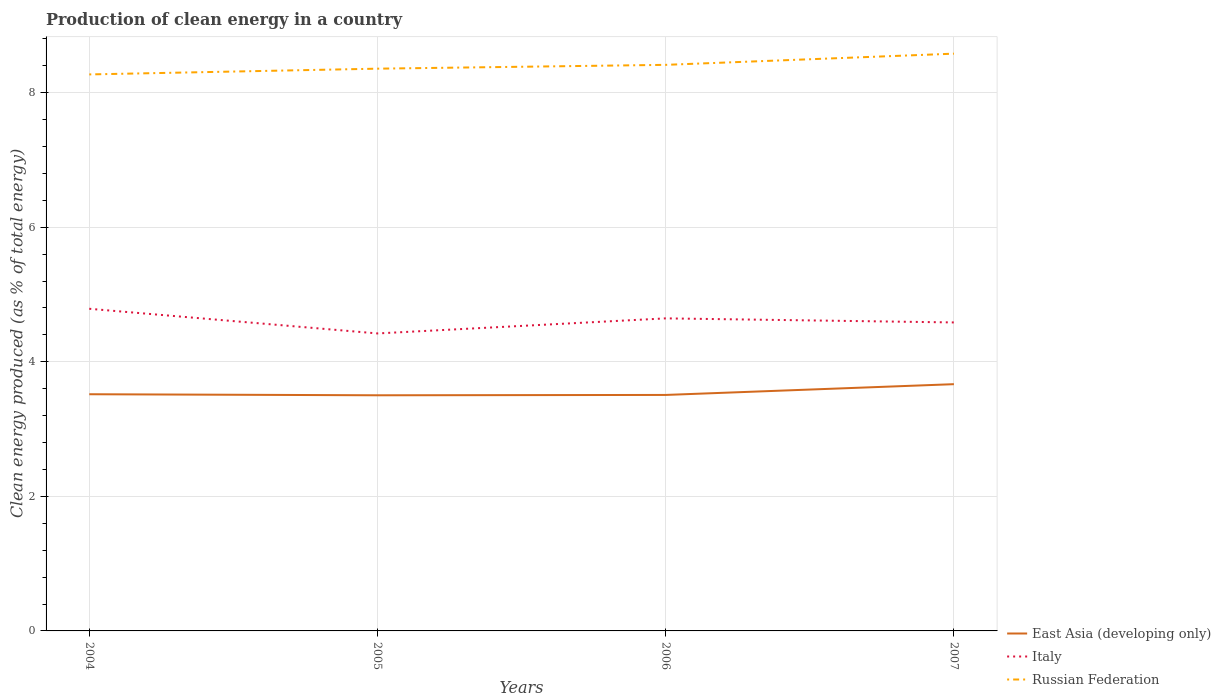Does the line corresponding to Italy intersect with the line corresponding to East Asia (developing only)?
Your response must be concise. No. Across all years, what is the maximum percentage of clean energy produced in Italy?
Your answer should be very brief. 4.42. In which year was the percentage of clean energy produced in East Asia (developing only) maximum?
Your answer should be very brief. 2005. What is the total percentage of clean energy produced in East Asia (developing only) in the graph?
Make the answer very short. 0.02. What is the difference between the highest and the second highest percentage of clean energy produced in Italy?
Provide a short and direct response. 0.37. Is the percentage of clean energy produced in Italy strictly greater than the percentage of clean energy produced in East Asia (developing only) over the years?
Your answer should be very brief. No. How many lines are there?
Your answer should be very brief. 3. How many years are there in the graph?
Provide a succinct answer. 4. Are the values on the major ticks of Y-axis written in scientific E-notation?
Your response must be concise. No. Does the graph contain grids?
Give a very brief answer. Yes. Where does the legend appear in the graph?
Ensure brevity in your answer.  Bottom right. What is the title of the graph?
Give a very brief answer. Production of clean energy in a country. What is the label or title of the X-axis?
Make the answer very short. Years. What is the label or title of the Y-axis?
Provide a short and direct response. Clean energy produced (as % of total energy). What is the Clean energy produced (as % of total energy) of East Asia (developing only) in 2004?
Offer a very short reply. 3.52. What is the Clean energy produced (as % of total energy) of Italy in 2004?
Make the answer very short. 4.79. What is the Clean energy produced (as % of total energy) of Russian Federation in 2004?
Make the answer very short. 8.27. What is the Clean energy produced (as % of total energy) in East Asia (developing only) in 2005?
Your response must be concise. 3.5. What is the Clean energy produced (as % of total energy) of Italy in 2005?
Offer a very short reply. 4.42. What is the Clean energy produced (as % of total energy) of Russian Federation in 2005?
Your answer should be very brief. 8.36. What is the Clean energy produced (as % of total energy) of East Asia (developing only) in 2006?
Keep it short and to the point. 3.51. What is the Clean energy produced (as % of total energy) in Italy in 2006?
Make the answer very short. 4.65. What is the Clean energy produced (as % of total energy) in Russian Federation in 2006?
Ensure brevity in your answer.  8.41. What is the Clean energy produced (as % of total energy) in East Asia (developing only) in 2007?
Your answer should be compact. 3.67. What is the Clean energy produced (as % of total energy) in Italy in 2007?
Give a very brief answer. 4.58. What is the Clean energy produced (as % of total energy) in Russian Federation in 2007?
Provide a succinct answer. 8.58. Across all years, what is the maximum Clean energy produced (as % of total energy) in East Asia (developing only)?
Your answer should be very brief. 3.67. Across all years, what is the maximum Clean energy produced (as % of total energy) in Italy?
Offer a very short reply. 4.79. Across all years, what is the maximum Clean energy produced (as % of total energy) of Russian Federation?
Provide a short and direct response. 8.58. Across all years, what is the minimum Clean energy produced (as % of total energy) of East Asia (developing only)?
Give a very brief answer. 3.5. Across all years, what is the minimum Clean energy produced (as % of total energy) in Italy?
Provide a short and direct response. 4.42. Across all years, what is the minimum Clean energy produced (as % of total energy) in Russian Federation?
Keep it short and to the point. 8.27. What is the total Clean energy produced (as % of total energy) of East Asia (developing only) in the graph?
Ensure brevity in your answer.  14.19. What is the total Clean energy produced (as % of total energy) of Italy in the graph?
Ensure brevity in your answer.  18.44. What is the total Clean energy produced (as % of total energy) in Russian Federation in the graph?
Give a very brief answer. 33.62. What is the difference between the Clean energy produced (as % of total energy) of East Asia (developing only) in 2004 and that in 2005?
Provide a short and direct response. 0.02. What is the difference between the Clean energy produced (as % of total energy) of Italy in 2004 and that in 2005?
Provide a succinct answer. 0.37. What is the difference between the Clean energy produced (as % of total energy) in Russian Federation in 2004 and that in 2005?
Your response must be concise. -0.09. What is the difference between the Clean energy produced (as % of total energy) of East Asia (developing only) in 2004 and that in 2006?
Make the answer very short. 0.01. What is the difference between the Clean energy produced (as % of total energy) of Italy in 2004 and that in 2006?
Offer a very short reply. 0.14. What is the difference between the Clean energy produced (as % of total energy) of Russian Federation in 2004 and that in 2006?
Your answer should be very brief. -0.14. What is the difference between the Clean energy produced (as % of total energy) of East Asia (developing only) in 2004 and that in 2007?
Ensure brevity in your answer.  -0.15. What is the difference between the Clean energy produced (as % of total energy) of Italy in 2004 and that in 2007?
Keep it short and to the point. 0.2. What is the difference between the Clean energy produced (as % of total energy) of Russian Federation in 2004 and that in 2007?
Ensure brevity in your answer.  -0.31. What is the difference between the Clean energy produced (as % of total energy) in East Asia (developing only) in 2005 and that in 2006?
Make the answer very short. -0.01. What is the difference between the Clean energy produced (as % of total energy) of Italy in 2005 and that in 2006?
Your answer should be very brief. -0.22. What is the difference between the Clean energy produced (as % of total energy) in Russian Federation in 2005 and that in 2006?
Ensure brevity in your answer.  -0.06. What is the difference between the Clean energy produced (as % of total energy) of East Asia (developing only) in 2005 and that in 2007?
Offer a terse response. -0.17. What is the difference between the Clean energy produced (as % of total energy) of Italy in 2005 and that in 2007?
Provide a succinct answer. -0.16. What is the difference between the Clean energy produced (as % of total energy) of Russian Federation in 2005 and that in 2007?
Your answer should be very brief. -0.22. What is the difference between the Clean energy produced (as % of total energy) of East Asia (developing only) in 2006 and that in 2007?
Offer a very short reply. -0.16. What is the difference between the Clean energy produced (as % of total energy) of Italy in 2006 and that in 2007?
Your answer should be very brief. 0.06. What is the difference between the Clean energy produced (as % of total energy) in Russian Federation in 2006 and that in 2007?
Your response must be concise. -0.17. What is the difference between the Clean energy produced (as % of total energy) in East Asia (developing only) in 2004 and the Clean energy produced (as % of total energy) in Italy in 2005?
Offer a very short reply. -0.9. What is the difference between the Clean energy produced (as % of total energy) in East Asia (developing only) in 2004 and the Clean energy produced (as % of total energy) in Russian Federation in 2005?
Offer a terse response. -4.84. What is the difference between the Clean energy produced (as % of total energy) in Italy in 2004 and the Clean energy produced (as % of total energy) in Russian Federation in 2005?
Provide a succinct answer. -3.57. What is the difference between the Clean energy produced (as % of total energy) of East Asia (developing only) in 2004 and the Clean energy produced (as % of total energy) of Italy in 2006?
Keep it short and to the point. -1.13. What is the difference between the Clean energy produced (as % of total energy) in East Asia (developing only) in 2004 and the Clean energy produced (as % of total energy) in Russian Federation in 2006?
Your answer should be compact. -4.9. What is the difference between the Clean energy produced (as % of total energy) of Italy in 2004 and the Clean energy produced (as % of total energy) of Russian Federation in 2006?
Offer a terse response. -3.63. What is the difference between the Clean energy produced (as % of total energy) of East Asia (developing only) in 2004 and the Clean energy produced (as % of total energy) of Italy in 2007?
Provide a succinct answer. -1.07. What is the difference between the Clean energy produced (as % of total energy) of East Asia (developing only) in 2004 and the Clean energy produced (as % of total energy) of Russian Federation in 2007?
Offer a terse response. -5.06. What is the difference between the Clean energy produced (as % of total energy) in Italy in 2004 and the Clean energy produced (as % of total energy) in Russian Federation in 2007?
Your answer should be compact. -3.79. What is the difference between the Clean energy produced (as % of total energy) of East Asia (developing only) in 2005 and the Clean energy produced (as % of total energy) of Italy in 2006?
Make the answer very short. -1.14. What is the difference between the Clean energy produced (as % of total energy) in East Asia (developing only) in 2005 and the Clean energy produced (as % of total energy) in Russian Federation in 2006?
Ensure brevity in your answer.  -4.91. What is the difference between the Clean energy produced (as % of total energy) of Italy in 2005 and the Clean energy produced (as % of total energy) of Russian Federation in 2006?
Your answer should be compact. -3.99. What is the difference between the Clean energy produced (as % of total energy) of East Asia (developing only) in 2005 and the Clean energy produced (as % of total energy) of Italy in 2007?
Offer a terse response. -1.08. What is the difference between the Clean energy produced (as % of total energy) in East Asia (developing only) in 2005 and the Clean energy produced (as % of total energy) in Russian Federation in 2007?
Provide a succinct answer. -5.08. What is the difference between the Clean energy produced (as % of total energy) of Italy in 2005 and the Clean energy produced (as % of total energy) of Russian Federation in 2007?
Provide a succinct answer. -4.16. What is the difference between the Clean energy produced (as % of total energy) in East Asia (developing only) in 2006 and the Clean energy produced (as % of total energy) in Italy in 2007?
Your answer should be compact. -1.08. What is the difference between the Clean energy produced (as % of total energy) of East Asia (developing only) in 2006 and the Clean energy produced (as % of total energy) of Russian Federation in 2007?
Offer a terse response. -5.07. What is the difference between the Clean energy produced (as % of total energy) in Italy in 2006 and the Clean energy produced (as % of total energy) in Russian Federation in 2007?
Provide a succinct answer. -3.93. What is the average Clean energy produced (as % of total energy) in East Asia (developing only) per year?
Ensure brevity in your answer.  3.55. What is the average Clean energy produced (as % of total energy) in Italy per year?
Ensure brevity in your answer.  4.61. What is the average Clean energy produced (as % of total energy) of Russian Federation per year?
Your answer should be very brief. 8.4. In the year 2004, what is the difference between the Clean energy produced (as % of total energy) in East Asia (developing only) and Clean energy produced (as % of total energy) in Italy?
Offer a very short reply. -1.27. In the year 2004, what is the difference between the Clean energy produced (as % of total energy) of East Asia (developing only) and Clean energy produced (as % of total energy) of Russian Federation?
Provide a short and direct response. -4.75. In the year 2004, what is the difference between the Clean energy produced (as % of total energy) of Italy and Clean energy produced (as % of total energy) of Russian Federation?
Your answer should be very brief. -3.48. In the year 2005, what is the difference between the Clean energy produced (as % of total energy) in East Asia (developing only) and Clean energy produced (as % of total energy) in Italy?
Your answer should be very brief. -0.92. In the year 2005, what is the difference between the Clean energy produced (as % of total energy) of East Asia (developing only) and Clean energy produced (as % of total energy) of Russian Federation?
Your response must be concise. -4.85. In the year 2005, what is the difference between the Clean energy produced (as % of total energy) in Italy and Clean energy produced (as % of total energy) in Russian Federation?
Provide a succinct answer. -3.94. In the year 2006, what is the difference between the Clean energy produced (as % of total energy) in East Asia (developing only) and Clean energy produced (as % of total energy) in Italy?
Make the answer very short. -1.14. In the year 2006, what is the difference between the Clean energy produced (as % of total energy) in East Asia (developing only) and Clean energy produced (as % of total energy) in Russian Federation?
Your answer should be very brief. -4.91. In the year 2006, what is the difference between the Clean energy produced (as % of total energy) of Italy and Clean energy produced (as % of total energy) of Russian Federation?
Offer a very short reply. -3.77. In the year 2007, what is the difference between the Clean energy produced (as % of total energy) of East Asia (developing only) and Clean energy produced (as % of total energy) of Italy?
Provide a succinct answer. -0.92. In the year 2007, what is the difference between the Clean energy produced (as % of total energy) in East Asia (developing only) and Clean energy produced (as % of total energy) in Russian Federation?
Your answer should be very brief. -4.91. In the year 2007, what is the difference between the Clean energy produced (as % of total energy) in Italy and Clean energy produced (as % of total energy) in Russian Federation?
Make the answer very short. -3.99. What is the ratio of the Clean energy produced (as % of total energy) of Italy in 2004 to that in 2005?
Offer a very short reply. 1.08. What is the ratio of the Clean energy produced (as % of total energy) of Russian Federation in 2004 to that in 2005?
Offer a very short reply. 0.99. What is the ratio of the Clean energy produced (as % of total energy) of Italy in 2004 to that in 2006?
Offer a terse response. 1.03. What is the ratio of the Clean energy produced (as % of total energy) in Russian Federation in 2004 to that in 2006?
Provide a short and direct response. 0.98. What is the ratio of the Clean energy produced (as % of total energy) of East Asia (developing only) in 2004 to that in 2007?
Your answer should be compact. 0.96. What is the ratio of the Clean energy produced (as % of total energy) in Italy in 2004 to that in 2007?
Offer a terse response. 1.04. What is the ratio of the Clean energy produced (as % of total energy) in East Asia (developing only) in 2005 to that in 2006?
Your response must be concise. 1. What is the ratio of the Clean energy produced (as % of total energy) in Italy in 2005 to that in 2006?
Ensure brevity in your answer.  0.95. What is the ratio of the Clean energy produced (as % of total energy) of East Asia (developing only) in 2005 to that in 2007?
Keep it short and to the point. 0.95. What is the ratio of the Clean energy produced (as % of total energy) in Italy in 2005 to that in 2007?
Offer a very short reply. 0.96. What is the ratio of the Clean energy produced (as % of total energy) in Russian Federation in 2005 to that in 2007?
Provide a succinct answer. 0.97. What is the ratio of the Clean energy produced (as % of total energy) of East Asia (developing only) in 2006 to that in 2007?
Give a very brief answer. 0.96. What is the ratio of the Clean energy produced (as % of total energy) in Italy in 2006 to that in 2007?
Provide a succinct answer. 1.01. What is the ratio of the Clean energy produced (as % of total energy) of Russian Federation in 2006 to that in 2007?
Provide a succinct answer. 0.98. What is the difference between the highest and the second highest Clean energy produced (as % of total energy) of East Asia (developing only)?
Your answer should be very brief. 0.15. What is the difference between the highest and the second highest Clean energy produced (as % of total energy) in Italy?
Your response must be concise. 0.14. What is the difference between the highest and the second highest Clean energy produced (as % of total energy) of Russian Federation?
Make the answer very short. 0.17. What is the difference between the highest and the lowest Clean energy produced (as % of total energy) in East Asia (developing only)?
Your answer should be very brief. 0.17. What is the difference between the highest and the lowest Clean energy produced (as % of total energy) of Italy?
Provide a succinct answer. 0.37. What is the difference between the highest and the lowest Clean energy produced (as % of total energy) in Russian Federation?
Provide a succinct answer. 0.31. 